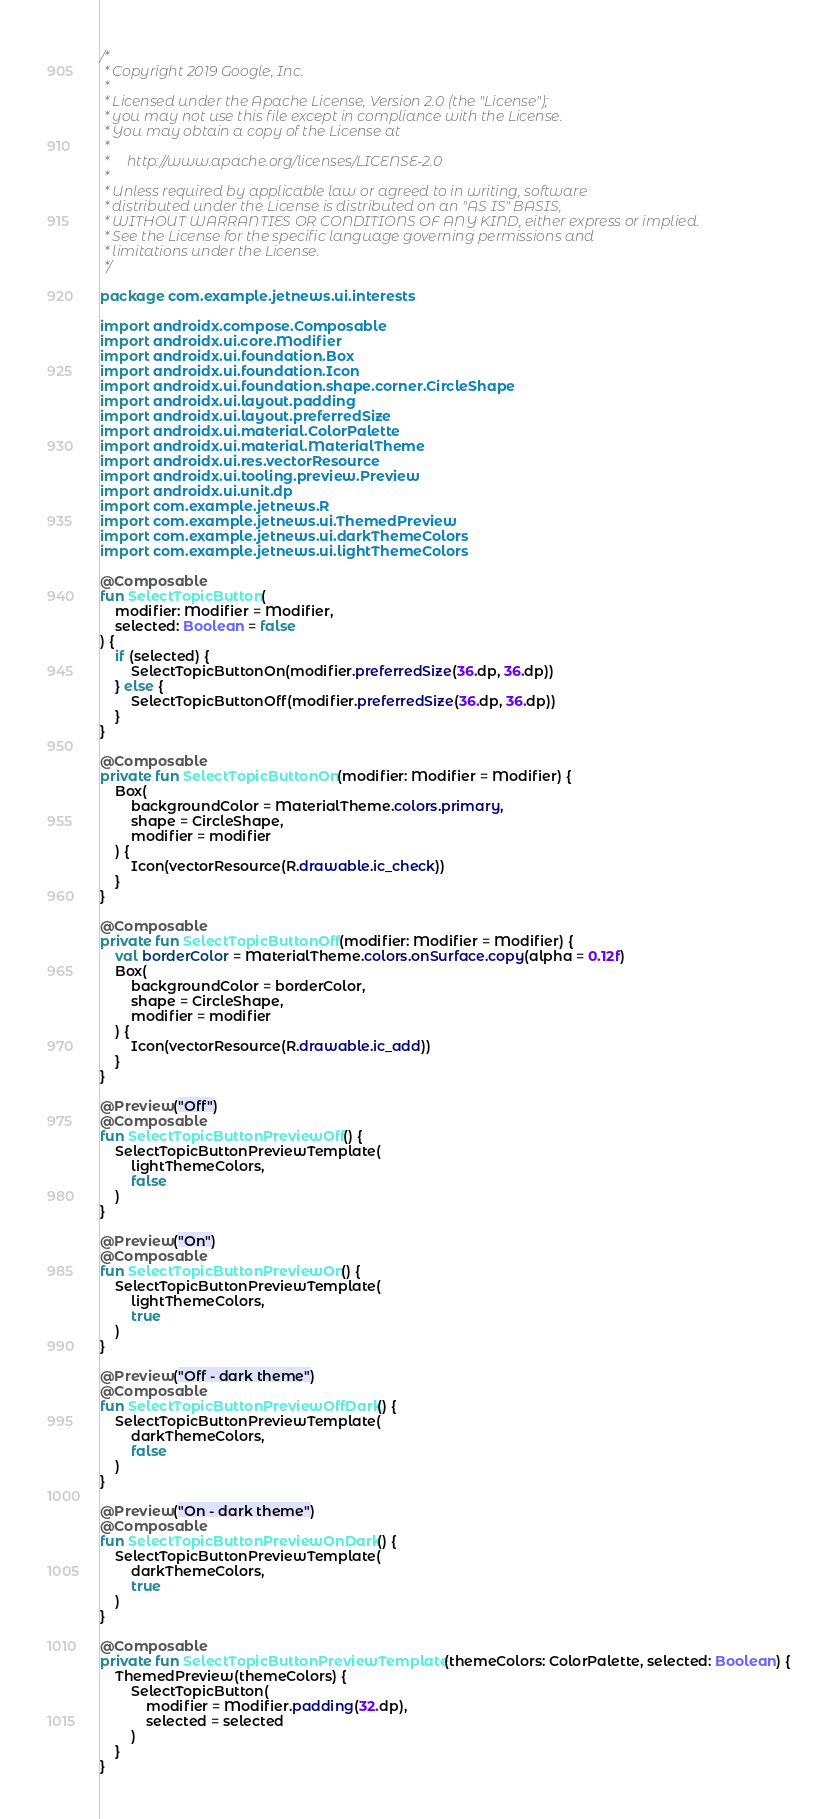<code> <loc_0><loc_0><loc_500><loc_500><_Kotlin_>/*
 * Copyright 2019 Google, Inc.
 *
 * Licensed under the Apache License, Version 2.0 (the "License");
 * you may not use this file except in compliance with the License.
 * You may obtain a copy of the License at
 *
 *     http://www.apache.org/licenses/LICENSE-2.0
 *
 * Unless required by applicable law or agreed to in writing, software
 * distributed under the License is distributed on an "AS IS" BASIS,
 * WITHOUT WARRANTIES OR CONDITIONS OF ANY KIND, either express or implied.
 * See the License for the specific language governing permissions and
 * limitations under the License.
 */

package com.example.jetnews.ui.interests

import androidx.compose.Composable
import androidx.ui.core.Modifier
import androidx.ui.foundation.Box
import androidx.ui.foundation.Icon
import androidx.ui.foundation.shape.corner.CircleShape
import androidx.ui.layout.padding
import androidx.ui.layout.preferredSize
import androidx.ui.material.ColorPalette
import androidx.ui.material.MaterialTheme
import androidx.ui.res.vectorResource
import androidx.ui.tooling.preview.Preview
import androidx.ui.unit.dp
import com.example.jetnews.R
import com.example.jetnews.ui.ThemedPreview
import com.example.jetnews.ui.darkThemeColors
import com.example.jetnews.ui.lightThemeColors

@Composable
fun SelectTopicButton(
    modifier: Modifier = Modifier,
    selected: Boolean = false
) {
    if (selected) {
        SelectTopicButtonOn(modifier.preferredSize(36.dp, 36.dp))
    } else {
        SelectTopicButtonOff(modifier.preferredSize(36.dp, 36.dp))
    }
}

@Composable
private fun SelectTopicButtonOn(modifier: Modifier = Modifier) {
    Box(
        backgroundColor = MaterialTheme.colors.primary,
        shape = CircleShape,
        modifier = modifier
    ) {
        Icon(vectorResource(R.drawable.ic_check))
    }
}

@Composable
private fun SelectTopicButtonOff(modifier: Modifier = Modifier) {
    val borderColor = MaterialTheme.colors.onSurface.copy(alpha = 0.12f)
    Box(
        backgroundColor = borderColor,
        shape = CircleShape,
        modifier = modifier
    ) {
        Icon(vectorResource(R.drawable.ic_add))
    }
}

@Preview("Off")
@Composable
fun SelectTopicButtonPreviewOff() {
    SelectTopicButtonPreviewTemplate(
        lightThemeColors,
        false
    )
}

@Preview("On")
@Composable
fun SelectTopicButtonPreviewOn() {
    SelectTopicButtonPreviewTemplate(
        lightThemeColors,
        true
    )
}

@Preview("Off - dark theme")
@Composable
fun SelectTopicButtonPreviewOffDark() {
    SelectTopicButtonPreviewTemplate(
        darkThemeColors,
        false
    )
}

@Preview("On - dark theme")
@Composable
fun SelectTopicButtonPreviewOnDark() {
    SelectTopicButtonPreviewTemplate(
        darkThemeColors,
        true
    )
}

@Composable
private fun SelectTopicButtonPreviewTemplate(themeColors: ColorPalette, selected: Boolean) {
    ThemedPreview(themeColors) {
        SelectTopicButton(
            modifier = Modifier.padding(32.dp),
            selected = selected
        )
    }
}
</code> 